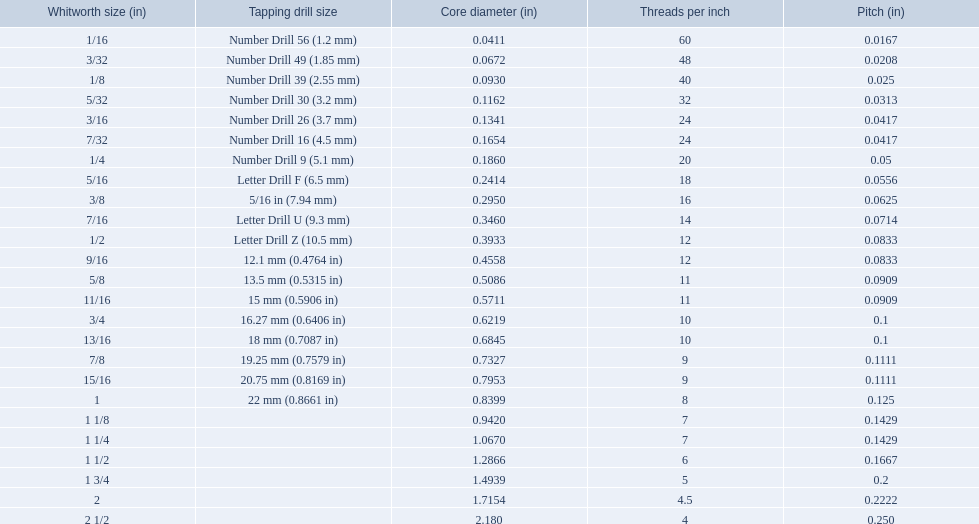A 1/16 whitworth has a core diameter of? 0.0411. Which whiteworth size has the same pitch as a 1/2? 9/16. 3/16 whiteworth has the same number of threads as? 7/32. 